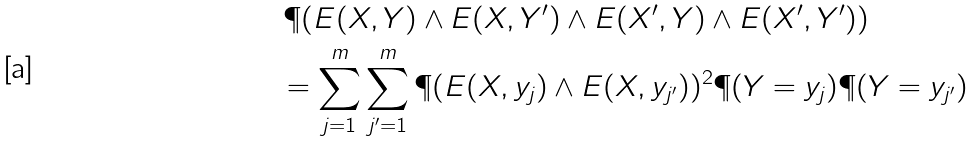<formula> <loc_0><loc_0><loc_500><loc_500>& \, \P ( E ( X , Y ) \wedge E ( X , Y ^ { \prime } ) \wedge E ( X ^ { \prime } , Y ) \wedge E ( X ^ { \prime } , Y ^ { \prime } ) ) \\ & = \sum _ { j = 1 } ^ { m } \sum _ { j ^ { \prime } = 1 } ^ { m } \P ( E ( X , y _ { j } ) \wedge E ( X , y _ { j ^ { \prime } } ) ) ^ { 2 } \P ( Y = y _ { j } ) \P ( Y = y _ { j ^ { \prime } } )</formula> 